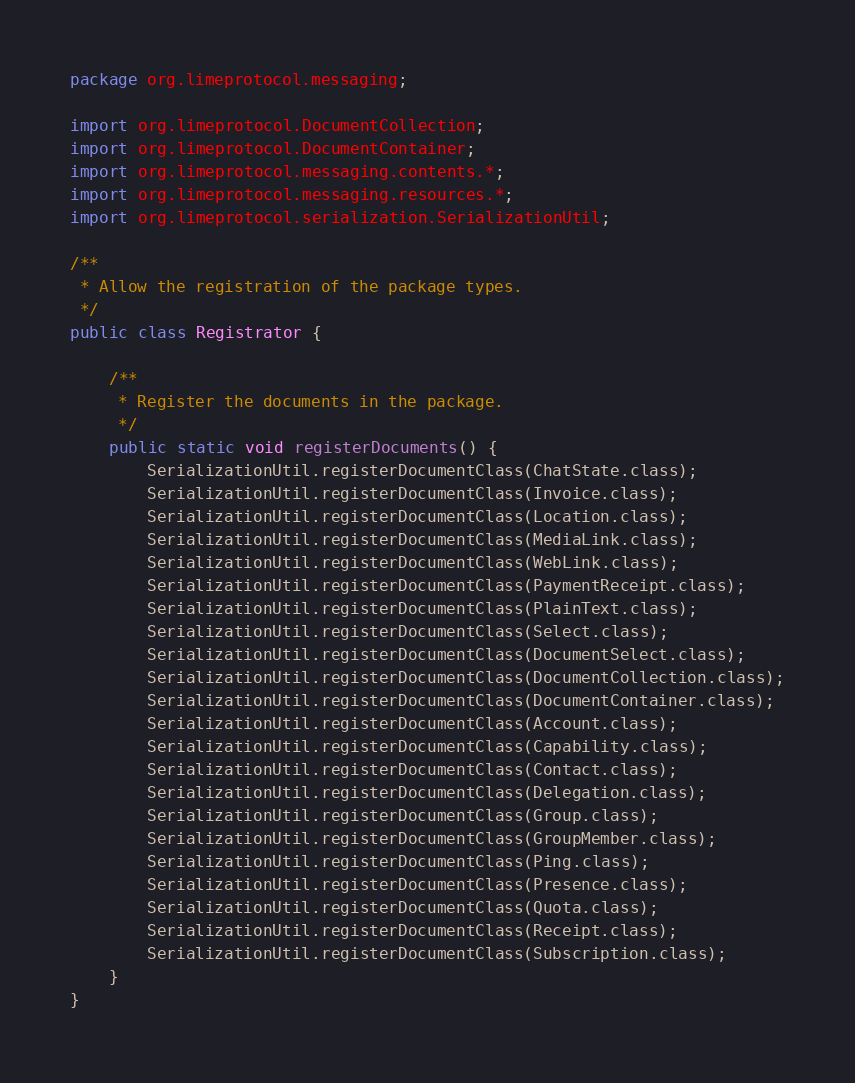Convert code to text. <code><loc_0><loc_0><loc_500><loc_500><_Java_>package org.limeprotocol.messaging;

import org.limeprotocol.DocumentCollection;
import org.limeprotocol.DocumentContainer;
import org.limeprotocol.messaging.contents.*;
import org.limeprotocol.messaging.resources.*;
import org.limeprotocol.serialization.SerializationUtil;

/**
 * Allow the registration of the package types.
 */
public class Registrator {

    /**
     * Register the documents in the package.
     */
    public static void registerDocuments() {
        SerializationUtil.registerDocumentClass(ChatState.class);
        SerializationUtil.registerDocumentClass(Invoice.class);
        SerializationUtil.registerDocumentClass(Location.class);
        SerializationUtil.registerDocumentClass(MediaLink.class);
        SerializationUtil.registerDocumentClass(WebLink.class);
        SerializationUtil.registerDocumentClass(PaymentReceipt.class);
        SerializationUtil.registerDocumentClass(PlainText.class);
        SerializationUtil.registerDocumentClass(Select.class);
        SerializationUtil.registerDocumentClass(DocumentSelect.class);
        SerializationUtil.registerDocumentClass(DocumentCollection.class);
        SerializationUtil.registerDocumentClass(DocumentContainer.class);
        SerializationUtil.registerDocumentClass(Account.class);
        SerializationUtil.registerDocumentClass(Capability.class);
        SerializationUtil.registerDocumentClass(Contact.class);
        SerializationUtil.registerDocumentClass(Delegation.class);
        SerializationUtil.registerDocumentClass(Group.class);
        SerializationUtil.registerDocumentClass(GroupMember.class);
        SerializationUtil.registerDocumentClass(Ping.class);
        SerializationUtil.registerDocumentClass(Presence.class);
        SerializationUtil.registerDocumentClass(Quota.class);
        SerializationUtil.registerDocumentClass(Receipt.class);
        SerializationUtil.registerDocumentClass(Subscription.class);
    }
}
</code> 